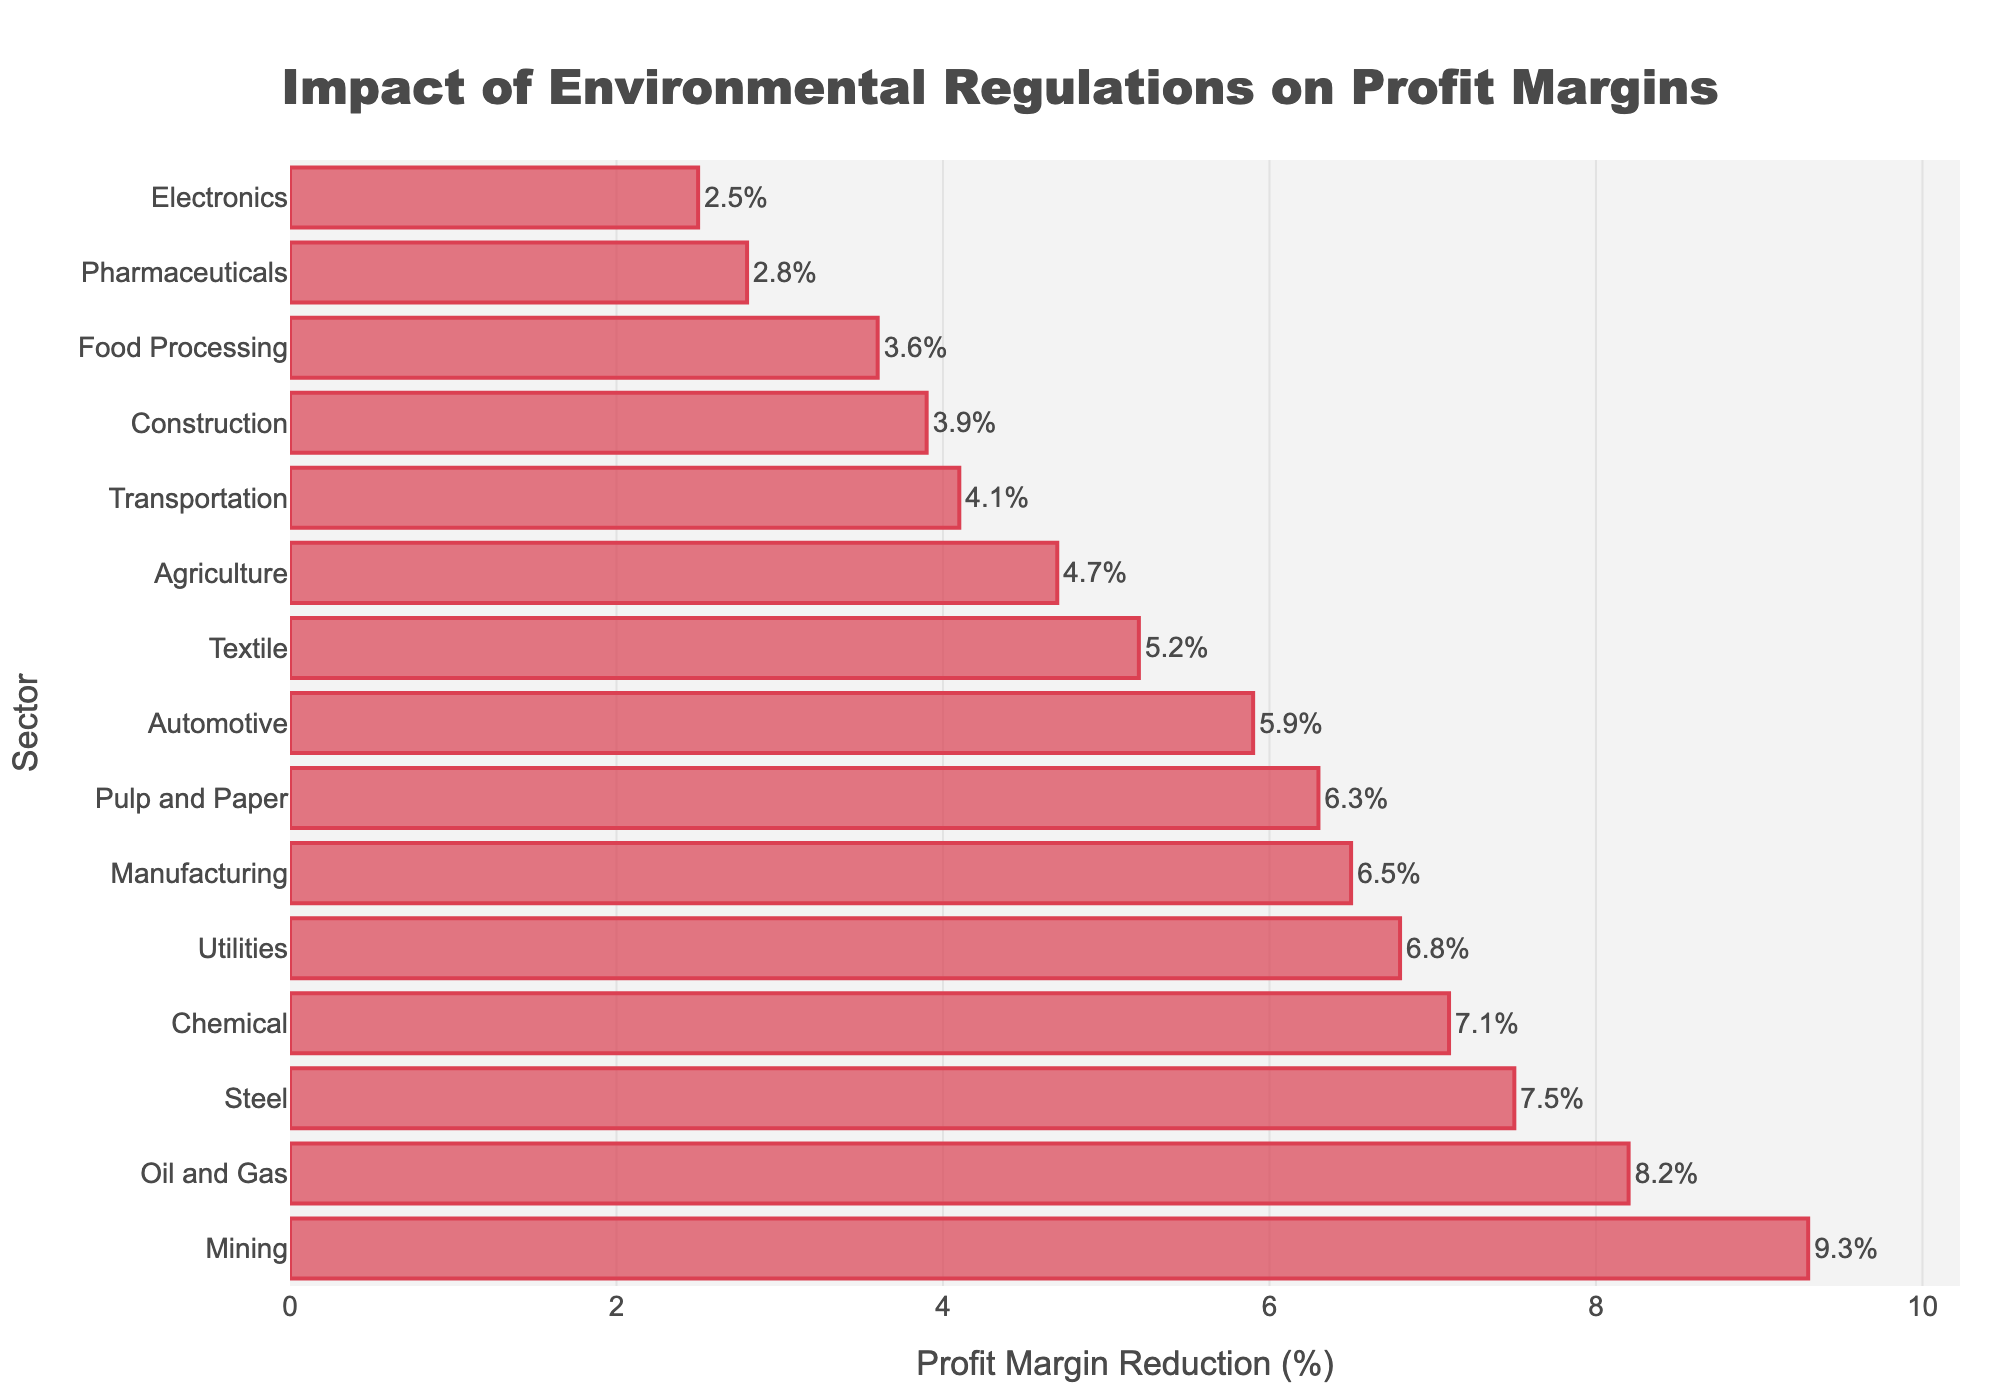Which sector experiences the highest profit margin reduction due to environmental regulations? By observing the longest bar in the chart, which represents the highest profit margin reduction, we can identify the sector.
Answer: Mining Which sector has a greater profit margin reduction, Oil and Gas or Pharmaceuticals? Compare the lengths of the bars for Oil and Gas and Pharmaceuticals. The Oil and Gas bar is longer, indicating a greater profit margin reduction.
Answer: Oil and Gas What is the average profit margin reduction for the top three sectors? Identify the top three sectors (Mining, Oil and Gas, and Steel) and calculate their average profit margin reduction: (9.3% + 8.2% + 7.5%) / 3 = 8.333%.
Answer: 8.3% Is the profit margin reduction for Chemicals more than or less than 7%? Look at the bar representing Chemicals and note its length in relation to the 7% mark on the x-axis. It reads slightly above 7%.
Answer: More Which sector has the smallest profit margin reduction and what is the value? Locate the shortest bar in the figure to find the sector and read the corresponding value.
Answer: Electronics, 2.5% How much more is the profit margin reduction for Utilities compared to Food Processing? Subtract the profit margin reduction of Food Processing from Utilities: 6.8% - 3.6% = 3.2%.
Answer: 3.2% Are there more sectors with a profit margin reduction above or below 5%? Count the number of bars above and below the 5% mark on the x-axis. There are 9 sectors above 5% and 6 sectors below 5%.
Answer: Above What is the total profit margin reduction for Agriculture and Textile sectors combined? Add the profit margin reductions for Agriculture and Textile: 4.7% + 5.2% = 9.9%.
Answer: 9.9% How do the profit margin reductions of Automotive and Pharmaceutical sectors compare? Compare the lengths of the bars for Automotive (5.9%) and Pharmaceuticals (2.8%). Automotive has a higher reduction.
Answer: Automotive What is the median profit margin reduction across all sectors presented? Arrange the profit margin reductions in ascending order and find the middle value: (2.5, 2.8, 3.6, 3.9, 4.1, 4.7, 5.2, 5.9, 6.3, 6.5, 6.8, 7.1, 7.5, 8.2, 9.3). The middle value or the 8th value is 5.9%.
Answer: 5.9% 